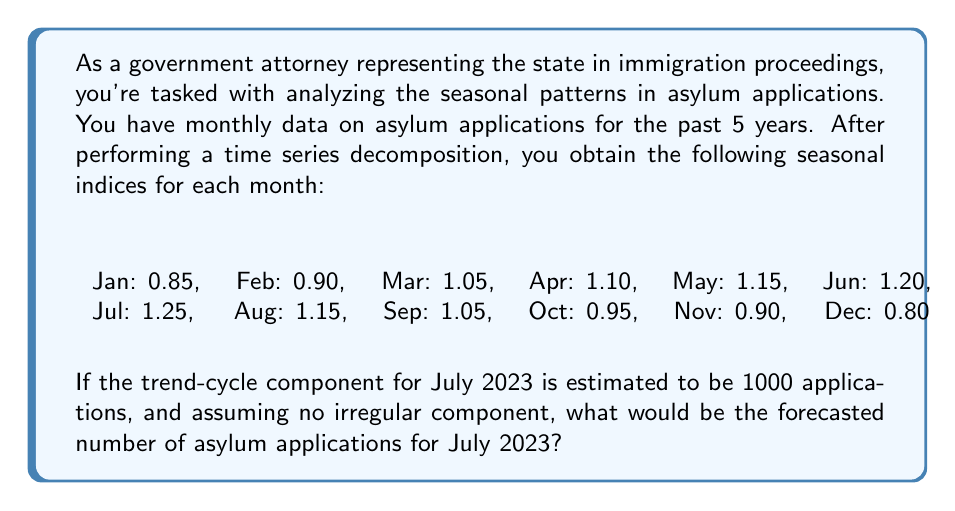Can you solve this math problem? To solve this problem, we need to understand the components of time series decomposition and how to use them for forecasting. The multiplicative time series model is given by:

$$ Y_t = T_t \times S_t \times I_t $$

Where:
$Y_t$ is the observed value
$T_t$ is the trend-cycle component
$S_t$ is the seasonal component
$I_t$ is the irregular component

In this case, we're assuming no irregular component $(I_t = 1)$, so our formula simplifies to:

$$ Y_t = T_t \times S_t $$

We're given:
1. The trend-cycle component for July 2023: $T_t = 1000$
2. The seasonal index for July: $S_t = 1.25$

To forecast the number of asylum applications for July 2023, we multiply these components:

$$ Y_t = 1000 \times 1.25 = 1250 $$

This means we expect 25% more applications in July compared to the trend-cycle component, due to the seasonal factor.
Answer: The forecasted number of asylum applications for July 2023 is 1250. 